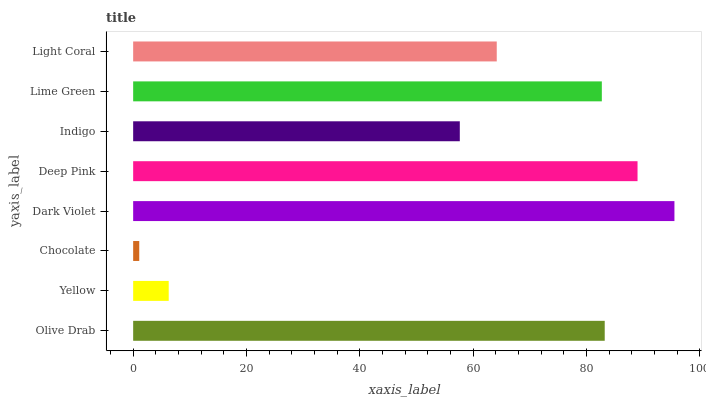Is Chocolate the minimum?
Answer yes or no. Yes. Is Dark Violet the maximum?
Answer yes or no. Yes. Is Yellow the minimum?
Answer yes or no. No. Is Yellow the maximum?
Answer yes or no. No. Is Olive Drab greater than Yellow?
Answer yes or no. Yes. Is Yellow less than Olive Drab?
Answer yes or no. Yes. Is Yellow greater than Olive Drab?
Answer yes or no. No. Is Olive Drab less than Yellow?
Answer yes or no. No. Is Lime Green the high median?
Answer yes or no. Yes. Is Light Coral the low median?
Answer yes or no. Yes. Is Dark Violet the high median?
Answer yes or no. No. Is Yellow the low median?
Answer yes or no. No. 